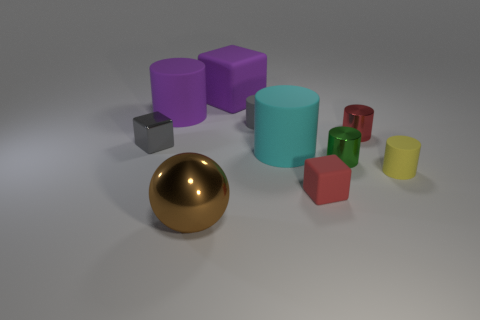Subtract all purple blocks. How many blocks are left? 2 Subtract all yellow cylinders. How many cylinders are left? 5 Subtract all cylinders. How many objects are left? 4 Add 3 red balls. How many red balls exist? 3 Subtract 1 gray cylinders. How many objects are left? 9 Subtract 1 spheres. How many spheres are left? 0 Subtract all purple spheres. Subtract all green blocks. How many spheres are left? 1 Subtract all tiny rubber things. Subtract all red things. How many objects are left? 5 Add 1 matte cubes. How many matte cubes are left? 3 